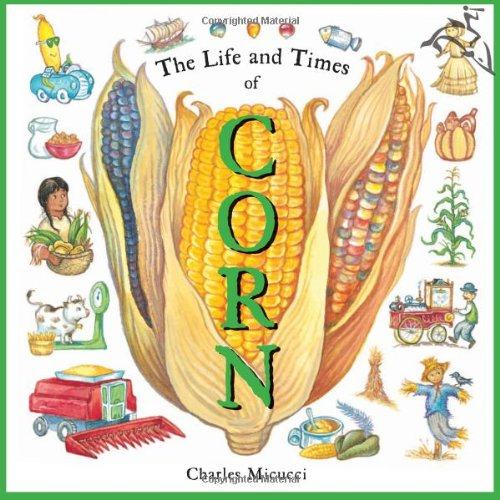Is this a kids book? Yes, this book is designed for children, featuring easy-to-understand language and vivid illustrations that make learning about corn both fun and educational. 